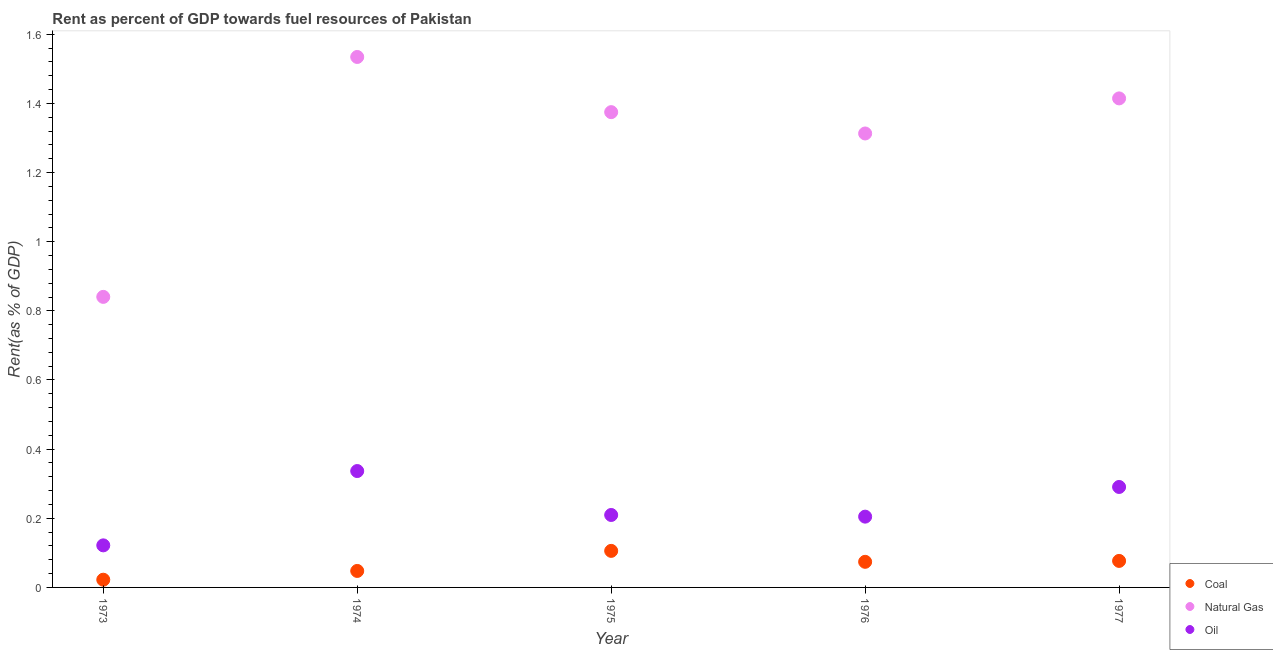How many different coloured dotlines are there?
Give a very brief answer. 3. What is the rent towards natural gas in 1973?
Your answer should be compact. 0.84. Across all years, what is the maximum rent towards natural gas?
Provide a short and direct response. 1.53. Across all years, what is the minimum rent towards coal?
Offer a very short reply. 0.02. In which year was the rent towards natural gas maximum?
Provide a succinct answer. 1974. What is the total rent towards natural gas in the graph?
Make the answer very short. 6.48. What is the difference between the rent towards coal in 1975 and that in 1976?
Your response must be concise. 0.03. What is the difference between the rent towards coal in 1975 and the rent towards oil in 1976?
Offer a very short reply. -0.1. What is the average rent towards oil per year?
Make the answer very short. 0.23. In the year 1977, what is the difference between the rent towards natural gas and rent towards coal?
Offer a very short reply. 1.34. What is the ratio of the rent towards coal in 1973 to that in 1977?
Offer a very short reply. 0.29. Is the difference between the rent towards natural gas in 1974 and 1976 greater than the difference between the rent towards oil in 1974 and 1976?
Your answer should be very brief. Yes. What is the difference between the highest and the second highest rent towards coal?
Make the answer very short. 0.03. What is the difference between the highest and the lowest rent towards coal?
Make the answer very short. 0.08. In how many years, is the rent towards natural gas greater than the average rent towards natural gas taken over all years?
Make the answer very short. 4. Is it the case that in every year, the sum of the rent towards coal and rent towards natural gas is greater than the rent towards oil?
Give a very brief answer. Yes. Is the rent towards natural gas strictly greater than the rent towards coal over the years?
Provide a short and direct response. Yes. Is the rent towards oil strictly less than the rent towards coal over the years?
Offer a terse response. No. How many dotlines are there?
Your answer should be compact. 3. Does the graph contain grids?
Give a very brief answer. No. Where does the legend appear in the graph?
Your answer should be compact. Bottom right. What is the title of the graph?
Offer a very short reply. Rent as percent of GDP towards fuel resources of Pakistan. What is the label or title of the X-axis?
Offer a terse response. Year. What is the label or title of the Y-axis?
Provide a succinct answer. Rent(as % of GDP). What is the Rent(as % of GDP) of Coal in 1973?
Give a very brief answer. 0.02. What is the Rent(as % of GDP) in Natural Gas in 1973?
Make the answer very short. 0.84. What is the Rent(as % of GDP) of Oil in 1973?
Your answer should be compact. 0.12. What is the Rent(as % of GDP) of Coal in 1974?
Offer a very short reply. 0.05. What is the Rent(as % of GDP) of Natural Gas in 1974?
Offer a very short reply. 1.53. What is the Rent(as % of GDP) of Oil in 1974?
Make the answer very short. 0.34. What is the Rent(as % of GDP) of Coal in 1975?
Ensure brevity in your answer.  0.11. What is the Rent(as % of GDP) in Natural Gas in 1975?
Provide a succinct answer. 1.37. What is the Rent(as % of GDP) of Oil in 1975?
Make the answer very short. 0.21. What is the Rent(as % of GDP) in Coal in 1976?
Offer a terse response. 0.07. What is the Rent(as % of GDP) in Natural Gas in 1976?
Your answer should be compact. 1.31. What is the Rent(as % of GDP) of Oil in 1976?
Offer a very short reply. 0.2. What is the Rent(as % of GDP) in Coal in 1977?
Your answer should be compact. 0.08. What is the Rent(as % of GDP) in Natural Gas in 1977?
Offer a very short reply. 1.41. What is the Rent(as % of GDP) of Oil in 1977?
Ensure brevity in your answer.  0.29. Across all years, what is the maximum Rent(as % of GDP) in Coal?
Your answer should be very brief. 0.11. Across all years, what is the maximum Rent(as % of GDP) of Natural Gas?
Keep it short and to the point. 1.53. Across all years, what is the maximum Rent(as % of GDP) in Oil?
Provide a short and direct response. 0.34. Across all years, what is the minimum Rent(as % of GDP) in Coal?
Your answer should be very brief. 0.02. Across all years, what is the minimum Rent(as % of GDP) in Natural Gas?
Offer a very short reply. 0.84. Across all years, what is the minimum Rent(as % of GDP) of Oil?
Your answer should be very brief. 0.12. What is the total Rent(as % of GDP) in Coal in the graph?
Provide a succinct answer. 0.33. What is the total Rent(as % of GDP) of Natural Gas in the graph?
Provide a short and direct response. 6.48. What is the total Rent(as % of GDP) in Oil in the graph?
Offer a very short reply. 1.16. What is the difference between the Rent(as % of GDP) of Coal in 1973 and that in 1974?
Your answer should be compact. -0.03. What is the difference between the Rent(as % of GDP) of Natural Gas in 1973 and that in 1974?
Your answer should be very brief. -0.69. What is the difference between the Rent(as % of GDP) in Oil in 1973 and that in 1974?
Your answer should be very brief. -0.21. What is the difference between the Rent(as % of GDP) of Coal in 1973 and that in 1975?
Offer a terse response. -0.08. What is the difference between the Rent(as % of GDP) of Natural Gas in 1973 and that in 1975?
Offer a terse response. -0.53. What is the difference between the Rent(as % of GDP) of Oil in 1973 and that in 1975?
Keep it short and to the point. -0.09. What is the difference between the Rent(as % of GDP) of Coal in 1973 and that in 1976?
Ensure brevity in your answer.  -0.05. What is the difference between the Rent(as % of GDP) in Natural Gas in 1973 and that in 1976?
Offer a terse response. -0.47. What is the difference between the Rent(as % of GDP) of Oil in 1973 and that in 1976?
Make the answer very short. -0.08. What is the difference between the Rent(as % of GDP) of Coal in 1973 and that in 1977?
Provide a succinct answer. -0.05. What is the difference between the Rent(as % of GDP) in Natural Gas in 1973 and that in 1977?
Ensure brevity in your answer.  -0.57. What is the difference between the Rent(as % of GDP) of Oil in 1973 and that in 1977?
Offer a very short reply. -0.17. What is the difference between the Rent(as % of GDP) in Coal in 1974 and that in 1975?
Offer a very short reply. -0.06. What is the difference between the Rent(as % of GDP) in Natural Gas in 1974 and that in 1975?
Provide a succinct answer. 0.16. What is the difference between the Rent(as % of GDP) in Oil in 1974 and that in 1975?
Ensure brevity in your answer.  0.13. What is the difference between the Rent(as % of GDP) in Coal in 1974 and that in 1976?
Offer a terse response. -0.03. What is the difference between the Rent(as % of GDP) in Natural Gas in 1974 and that in 1976?
Ensure brevity in your answer.  0.22. What is the difference between the Rent(as % of GDP) in Oil in 1974 and that in 1976?
Make the answer very short. 0.13. What is the difference between the Rent(as % of GDP) of Coal in 1974 and that in 1977?
Give a very brief answer. -0.03. What is the difference between the Rent(as % of GDP) in Natural Gas in 1974 and that in 1977?
Keep it short and to the point. 0.12. What is the difference between the Rent(as % of GDP) of Oil in 1974 and that in 1977?
Ensure brevity in your answer.  0.05. What is the difference between the Rent(as % of GDP) of Coal in 1975 and that in 1976?
Ensure brevity in your answer.  0.03. What is the difference between the Rent(as % of GDP) of Natural Gas in 1975 and that in 1976?
Your answer should be compact. 0.06. What is the difference between the Rent(as % of GDP) of Oil in 1975 and that in 1976?
Your response must be concise. 0. What is the difference between the Rent(as % of GDP) of Coal in 1975 and that in 1977?
Your answer should be very brief. 0.03. What is the difference between the Rent(as % of GDP) in Natural Gas in 1975 and that in 1977?
Offer a terse response. -0.04. What is the difference between the Rent(as % of GDP) in Oil in 1975 and that in 1977?
Your response must be concise. -0.08. What is the difference between the Rent(as % of GDP) in Coal in 1976 and that in 1977?
Offer a very short reply. -0. What is the difference between the Rent(as % of GDP) in Natural Gas in 1976 and that in 1977?
Give a very brief answer. -0.1. What is the difference between the Rent(as % of GDP) of Oil in 1976 and that in 1977?
Ensure brevity in your answer.  -0.09. What is the difference between the Rent(as % of GDP) of Coal in 1973 and the Rent(as % of GDP) of Natural Gas in 1974?
Make the answer very short. -1.51. What is the difference between the Rent(as % of GDP) of Coal in 1973 and the Rent(as % of GDP) of Oil in 1974?
Offer a terse response. -0.31. What is the difference between the Rent(as % of GDP) of Natural Gas in 1973 and the Rent(as % of GDP) of Oil in 1974?
Your answer should be very brief. 0.5. What is the difference between the Rent(as % of GDP) of Coal in 1973 and the Rent(as % of GDP) of Natural Gas in 1975?
Your response must be concise. -1.35. What is the difference between the Rent(as % of GDP) in Coal in 1973 and the Rent(as % of GDP) in Oil in 1975?
Offer a very short reply. -0.19. What is the difference between the Rent(as % of GDP) of Natural Gas in 1973 and the Rent(as % of GDP) of Oil in 1975?
Your answer should be compact. 0.63. What is the difference between the Rent(as % of GDP) of Coal in 1973 and the Rent(as % of GDP) of Natural Gas in 1976?
Provide a succinct answer. -1.29. What is the difference between the Rent(as % of GDP) in Coal in 1973 and the Rent(as % of GDP) in Oil in 1976?
Your answer should be compact. -0.18. What is the difference between the Rent(as % of GDP) of Natural Gas in 1973 and the Rent(as % of GDP) of Oil in 1976?
Offer a very short reply. 0.64. What is the difference between the Rent(as % of GDP) of Coal in 1973 and the Rent(as % of GDP) of Natural Gas in 1977?
Give a very brief answer. -1.39. What is the difference between the Rent(as % of GDP) of Coal in 1973 and the Rent(as % of GDP) of Oil in 1977?
Ensure brevity in your answer.  -0.27. What is the difference between the Rent(as % of GDP) of Natural Gas in 1973 and the Rent(as % of GDP) of Oil in 1977?
Provide a short and direct response. 0.55. What is the difference between the Rent(as % of GDP) of Coal in 1974 and the Rent(as % of GDP) of Natural Gas in 1975?
Keep it short and to the point. -1.33. What is the difference between the Rent(as % of GDP) of Coal in 1974 and the Rent(as % of GDP) of Oil in 1975?
Keep it short and to the point. -0.16. What is the difference between the Rent(as % of GDP) of Natural Gas in 1974 and the Rent(as % of GDP) of Oil in 1975?
Your answer should be compact. 1.32. What is the difference between the Rent(as % of GDP) in Coal in 1974 and the Rent(as % of GDP) in Natural Gas in 1976?
Provide a short and direct response. -1.27. What is the difference between the Rent(as % of GDP) of Coal in 1974 and the Rent(as % of GDP) of Oil in 1976?
Your answer should be compact. -0.16. What is the difference between the Rent(as % of GDP) in Natural Gas in 1974 and the Rent(as % of GDP) in Oil in 1976?
Give a very brief answer. 1.33. What is the difference between the Rent(as % of GDP) in Coal in 1974 and the Rent(as % of GDP) in Natural Gas in 1977?
Offer a terse response. -1.37. What is the difference between the Rent(as % of GDP) in Coal in 1974 and the Rent(as % of GDP) in Oil in 1977?
Provide a short and direct response. -0.24. What is the difference between the Rent(as % of GDP) of Natural Gas in 1974 and the Rent(as % of GDP) of Oil in 1977?
Ensure brevity in your answer.  1.24. What is the difference between the Rent(as % of GDP) in Coal in 1975 and the Rent(as % of GDP) in Natural Gas in 1976?
Your answer should be compact. -1.21. What is the difference between the Rent(as % of GDP) in Coal in 1975 and the Rent(as % of GDP) in Oil in 1976?
Provide a short and direct response. -0.1. What is the difference between the Rent(as % of GDP) in Natural Gas in 1975 and the Rent(as % of GDP) in Oil in 1976?
Offer a terse response. 1.17. What is the difference between the Rent(as % of GDP) in Coal in 1975 and the Rent(as % of GDP) in Natural Gas in 1977?
Provide a short and direct response. -1.31. What is the difference between the Rent(as % of GDP) in Coal in 1975 and the Rent(as % of GDP) in Oil in 1977?
Make the answer very short. -0.18. What is the difference between the Rent(as % of GDP) of Natural Gas in 1975 and the Rent(as % of GDP) of Oil in 1977?
Keep it short and to the point. 1.08. What is the difference between the Rent(as % of GDP) in Coal in 1976 and the Rent(as % of GDP) in Natural Gas in 1977?
Make the answer very short. -1.34. What is the difference between the Rent(as % of GDP) in Coal in 1976 and the Rent(as % of GDP) in Oil in 1977?
Offer a terse response. -0.22. What is the difference between the Rent(as % of GDP) of Natural Gas in 1976 and the Rent(as % of GDP) of Oil in 1977?
Provide a short and direct response. 1.02. What is the average Rent(as % of GDP) in Coal per year?
Offer a very short reply. 0.07. What is the average Rent(as % of GDP) of Natural Gas per year?
Provide a succinct answer. 1.3. What is the average Rent(as % of GDP) in Oil per year?
Keep it short and to the point. 0.23. In the year 1973, what is the difference between the Rent(as % of GDP) of Coal and Rent(as % of GDP) of Natural Gas?
Your answer should be compact. -0.82. In the year 1973, what is the difference between the Rent(as % of GDP) in Coal and Rent(as % of GDP) in Oil?
Ensure brevity in your answer.  -0.1. In the year 1973, what is the difference between the Rent(as % of GDP) of Natural Gas and Rent(as % of GDP) of Oil?
Provide a succinct answer. 0.72. In the year 1974, what is the difference between the Rent(as % of GDP) of Coal and Rent(as % of GDP) of Natural Gas?
Provide a succinct answer. -1.49. In the year 1974, what is the difference between the Rent(as % of GDP) of Coal and Rent(as % of GDP) of Oil?
Give a very brief answer. -0.29. In the year 1974, what is the difference between the Rent(as % of GDP) in Natural Gas and Rent(as % of GDP) in Oil?
Make the answer very short. 1.2. In the year 1975, what is the difference between the Rent(as % of GDP) of Coal and Rent(as % of GDP) of Natural Gas?
Provide a succinct answer. -1.27. In the year 1975, what is the difference between the Rent(as % of GDP) of Coal and Rent(as % of GDP) of Oil?
Your response must be concise. -0.1. In the year 1975, what is the difference between the Rent(as % of GDP) in Natural Gas and Rent(as % of GDP) in Oil?
Provide a short and direct response. 1.17. In the year 1976, what is the difference between the Rent(as % of GDP) in Coal and Rent(as % of GDP) in Natural Gas?
Keep it short and to the point. -1.24. In the year 1976, what is the difference between the Rent(as % of GDP) in Coal and Rent(as % of GDP) in Oil?
Your answer should be compact. -0.13. In the year 1976, what is the difference between the Rent(as % of GDP) of Natural Gas and Rent(as % of GDP) of Oil?
Provide a short and direct response. 1.11. In the year 1977, what is the difference between the Rent(as % of GDP) of Coal and Rent(as % of GDP) of Natural Gas?
Your response must be concise. -1.34. In the year 1977, what is the difference between the Rent(as % of GDP) of Coal and Rent(as % of GDP) of Oil?
Provide a succinct answer. -0.21. In the year 1977, what is the difference between the Rent(as % of GDP) in Natural Gas and Rent(as % of GDP) in Oil?
Your response must be concise. 1.12. What is the ratio of the Rent(as % of GDP) of Coal in 1973 to that in 1974?
Offer a very short reply. 0.47. What is the ratio of the Rent(as % of GDP) of Natural Gas in 1973 to that in 1974?
Give a very brief answer. 0.55. What is the ratio of the Rent(as % of GDP) of Oil in 1973 to that in 1974?
Your answer should be compact. 0.36. What is the ratio of the Rent(as % of GDP) in Coal in 1973 to that in 1975?
Your answer should be compact. 0.21. What is the ratio of the Rent(as % of GDP) in Natural Gas in 1973 to that in 1975?
Provide a succinct answer. 0.61. What is the ratio of the Rent(as % of GDP) in Oil in 1973 to that in 1975?
Provide a short and direct response. 0.58. What is the ratio of the Rent(as % of GDP) in Coal in 1973 to that in 1976?
Your answer should be very brief. 0.3. What is the ratio of the Rent(as % of GDP) of Natural Gas in 1973 to that in 1976?
Give a very brief answer. 0.64. What is the ratio of the Rent(as % of GDP) in Oil in 1973 to that in 1976?
Your answer should be very brief. 0.59. What is the ratio of the Rent(as % of GDP) of Coal in 1973 to that in 1977?
Offer a terse response. 0.29. What is the ratio of the Rent(as % of GDP) of Natural Gas in 1973 to that in 1977?
Provide a succinct answer. 0.59. What is the ratio of the Rent(as % of GDP) in Oil in 1973 to that in 1977?
Ensure brevity in your answer.  0.42. What is the ratio of the Rent(as % of GDP) of Coal in 1974 to that in 1975?
Give a very brief answer. 0.45. What is the ratio of the Rent(as % of GDP) in Natural Gas in 1974 to that in 1975?
Ensure brevity in your answer.  1.12. What is the ratio of the Rent(as % of GDP) of Oil in 1974 to that in 1975?
Provide a succinct answer. 1.61. What is the ratio of the Rent(as % of GDP) in Coal in 1974 to that in 1976?
Your answer should be compact. 0.64. What is the ratio of the Rent(as % of GDP) of Natural Gas in 1974 to that in 1976?
Provide a short and direct response. 1.17. What is the ratio of the Rent(as % of GDP) in Oil in 1974 to that in 1976?
Your answer should be very brief. 1.64. What is the ratio of the Rent(as % of GDP) of Coal in 1974 to that in 1977?
Your answer should be compact. 0.62. What is the ratio of the Rent(as % of GDP) in Natural Gas in 1974 to that in 1977?
Make the answer very short. 1.08. What is the ratio of the Rent(as % of GDP) of Oil in 1974 to that in 1977?
Provide a short and direct response. 1.16. What is the ratio of the Rent(as % of GDP) of Coal in 1975 to that in 1976?
Your answer should be compact. 1.43. What is the ratio of the Rent(as % of GDP) in Natural Gas in 1975 to that in 1976?
Your answer should be very brief. 1.05. What is the ratio of the Rent(as % of GDP) of Oil in 1975 to that in 1976?
Your answer should be very brief. 1.02. What is the ratio of the Rent(as % of GDP) of Coal in 1975 to that in 1977?
Your response must be concise. 1.38. What is the ratio of the Rent(as % of GDP) in Natural Gas in 1975 to that in 1977?
Provide a short and direct response. 0.97. What is the ratio of the Rent(as % of GDP) of Oil in 1975 to that in 1977?
Your response must be concise. 0.72. What is the ratio of the Rent(as % of GDP) of Coal in 1976 to that in 1977?
Offer a very short reply. 0.97. What is the ratio of the Rent(as % of GDP) of Natural Gas in 1976 to that in 1977?
Make the answer very short. 0.93. What is the ratio of the Rent(as % of GDP) of Oil in 1976 to that in 1977?
Provide a short and direct response. 0.7. What is the difference between the highest and the second highest Rent(as % of GDP) of Coal?
Your response must be concise. 0.03. What is the difference between the highest and the second highest Rent(as % of GDP) in Natural Gas?
Provide a short and direct response. 0.12. What is the difference between the highest and the second highest Rent(as % of GDP) in Oil?
Your response must be concise. 0.05. What is the difference between the highest and the lowest Rent(as % of GDP) in Coal?
Your answer should be compact. 0.08. What is the difference between the highest and the lowest Rent(as % of GDP) in Natural Gas?
Your answer should be compact. 0.69. What is the difference between the highest and the lowest Rent(as % of GDP) of Oil?
Offer a very short reply. 0.21. 